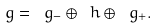<formula> <loc_0><loc_0><loc_500><loc_500>\ g = \ g _ { - } \oplus \ h \oplus \ g _ { + } .</formula> 